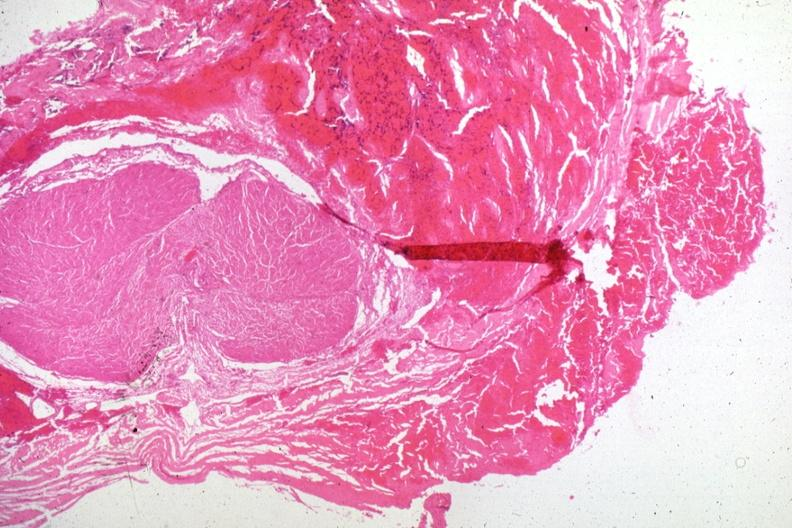does conjoined twins show hemorrhagic tissue in region of lesion several slides on this case?
Answer the question using a single word or phrase. No 